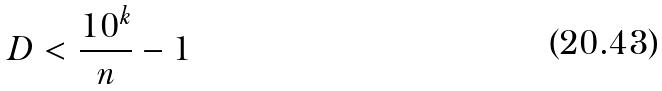<formula> <loc_0><loc_0><loc_500><loc_500>D < \frac { 1 0 ^ { k } } { n } - 1</formula> 